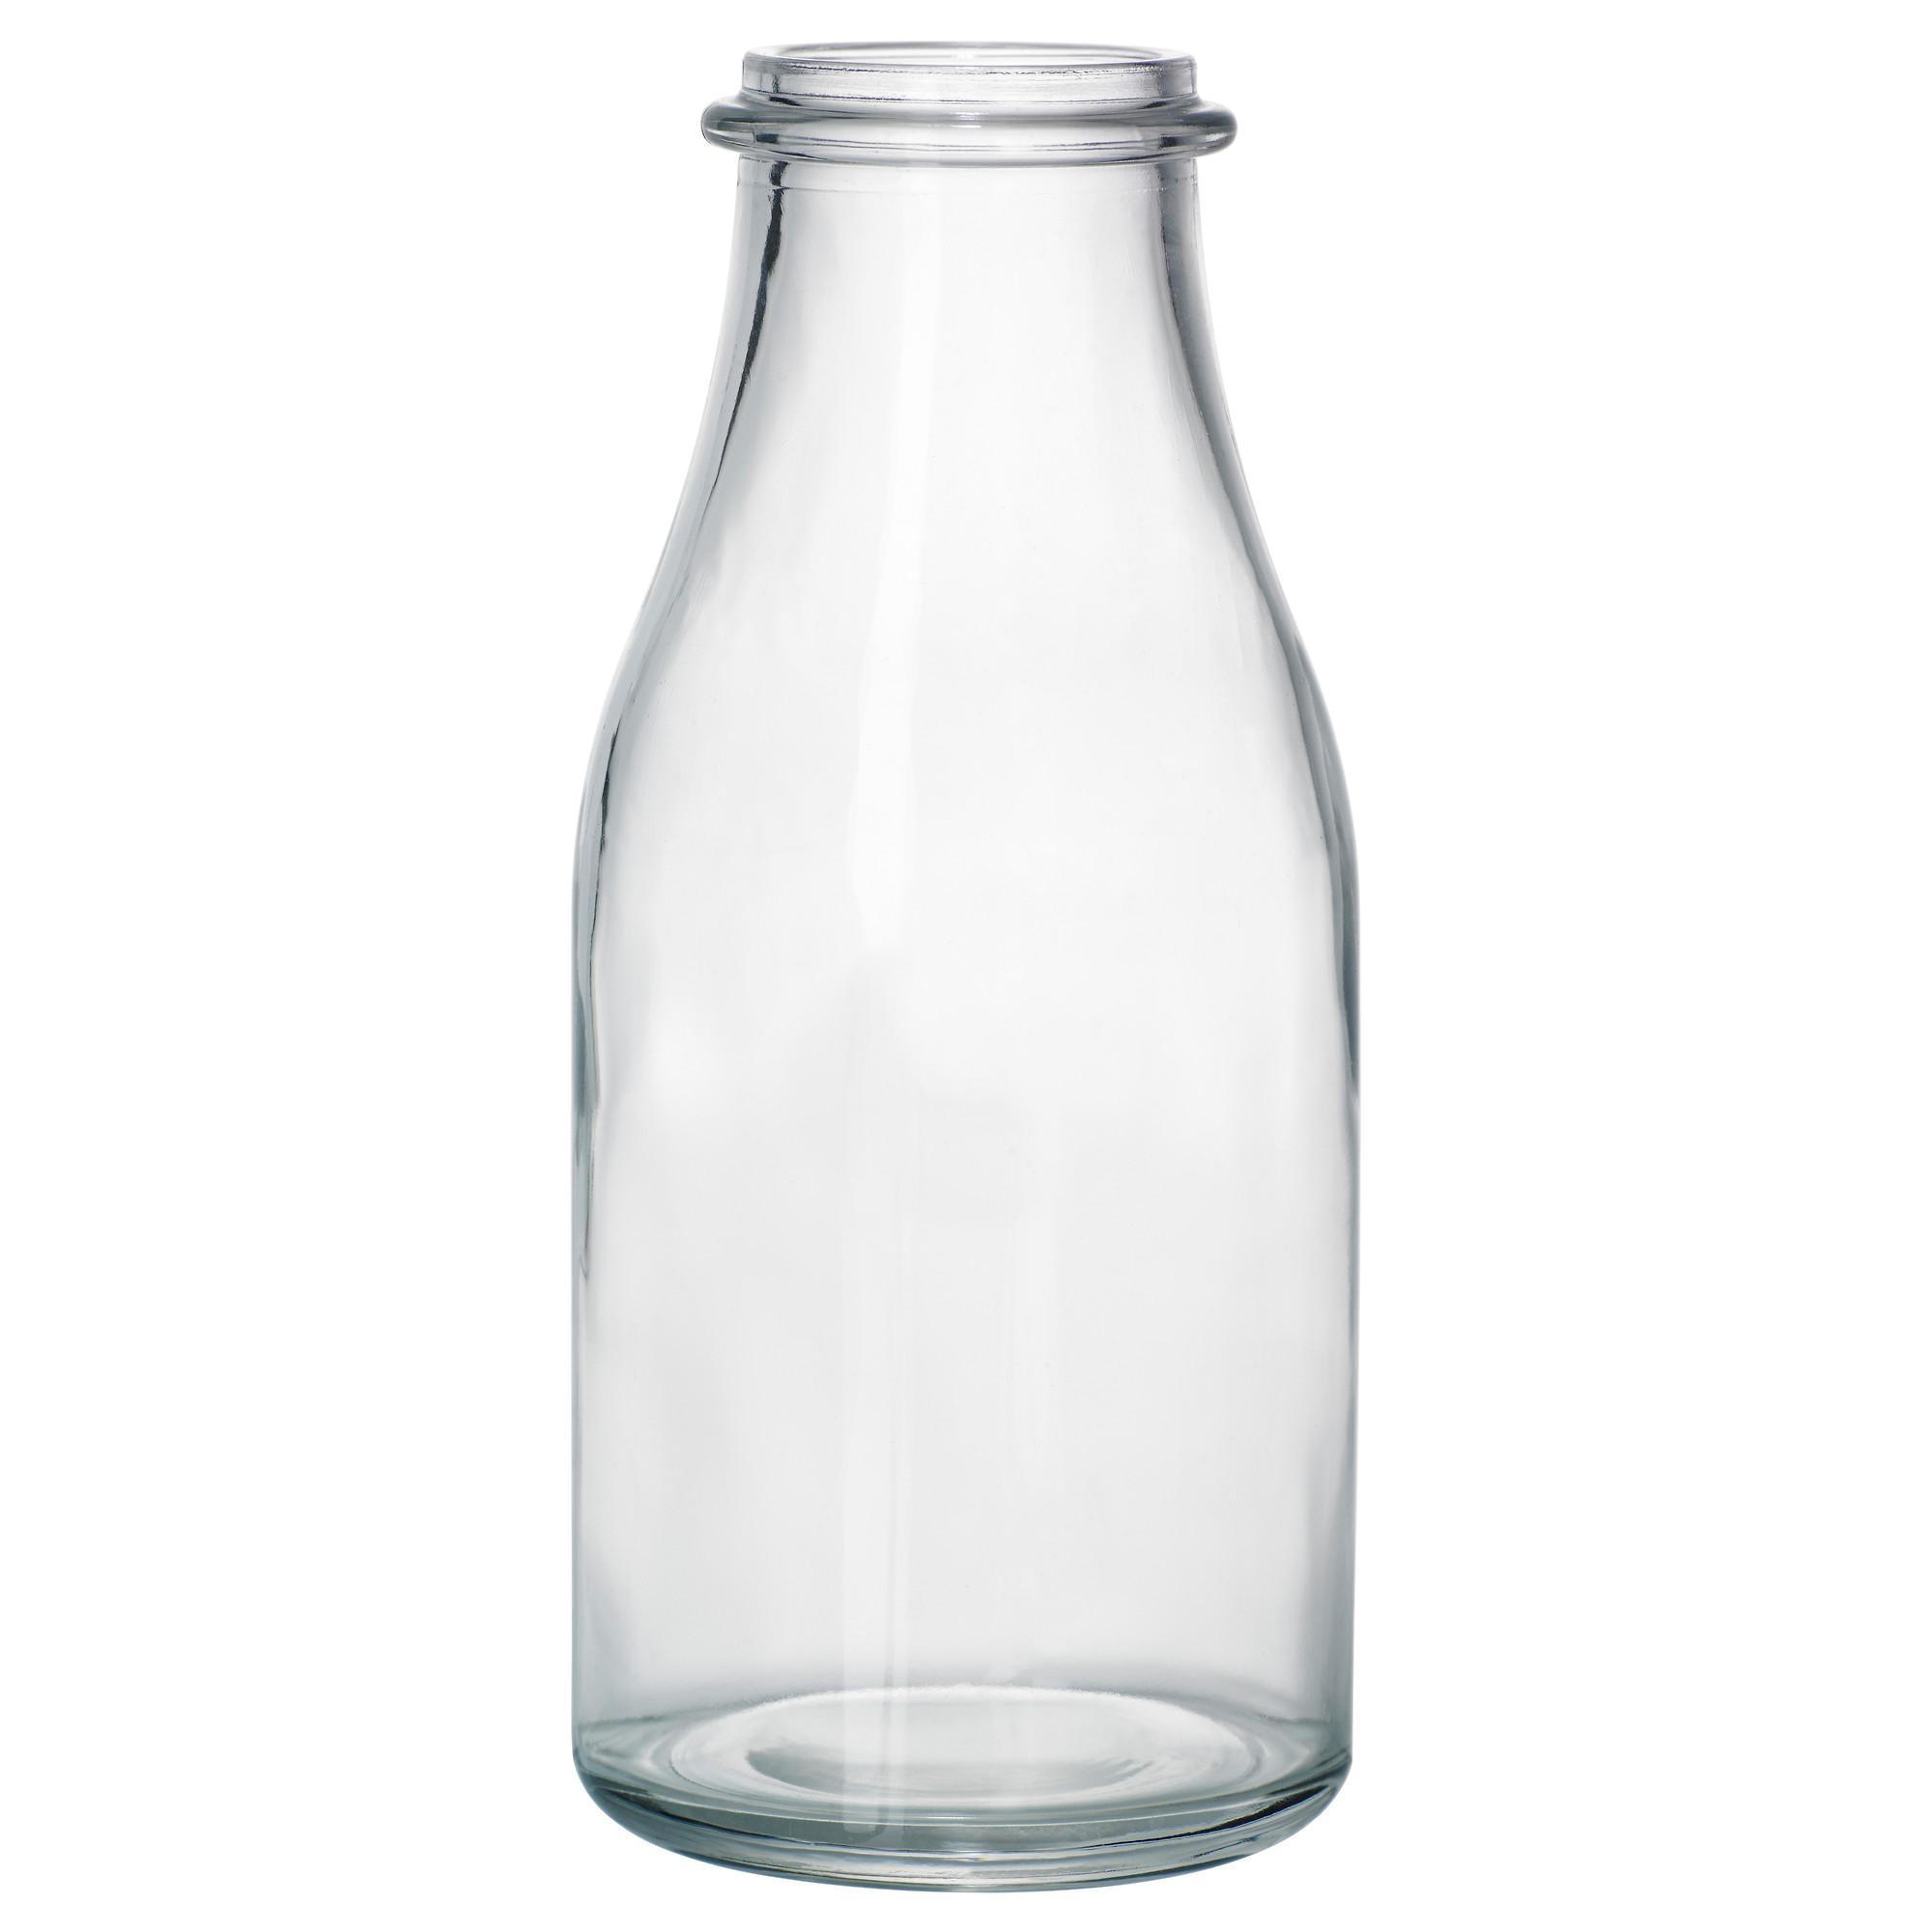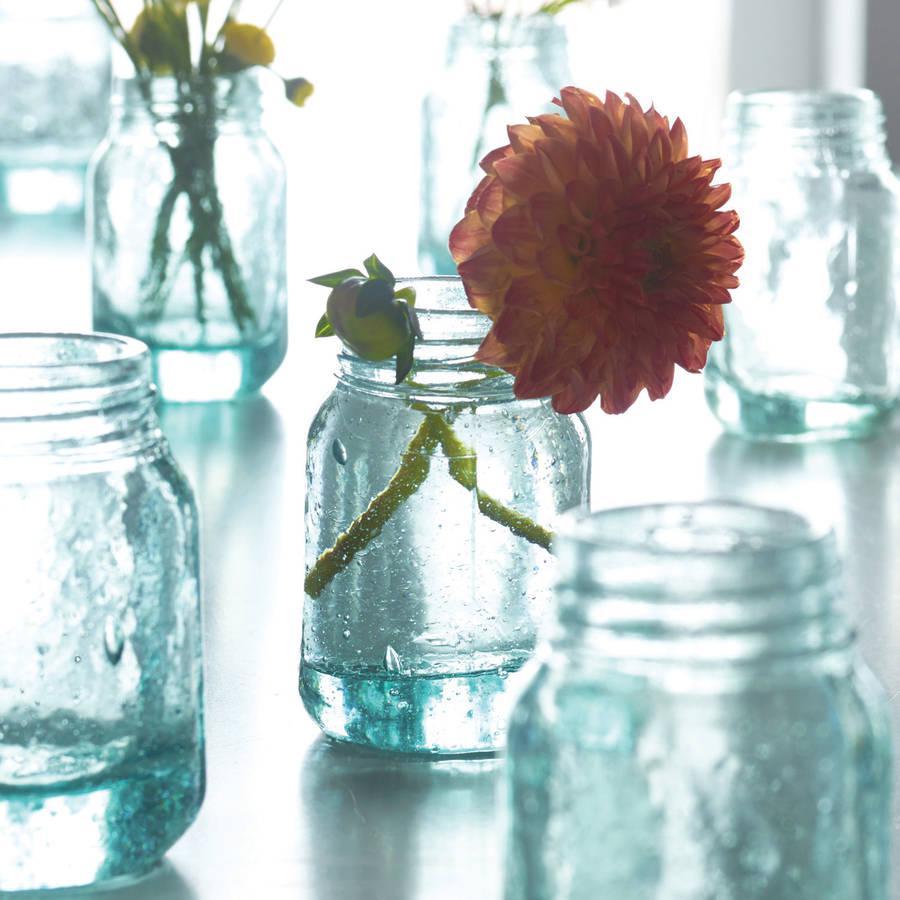The first image is the image on the left, the second image is the image on the right. Assess this claim about the two images: "There are at least 5 glass jars.". Correct or not? Answer yes or no. Yes. The first image is the image on the left, the second image is the image on the right. Evaluate the accuracy of this statement regarding the images: "The vases are made of repurposed bottles.". Is it true? Answer yes or no. Yes. 